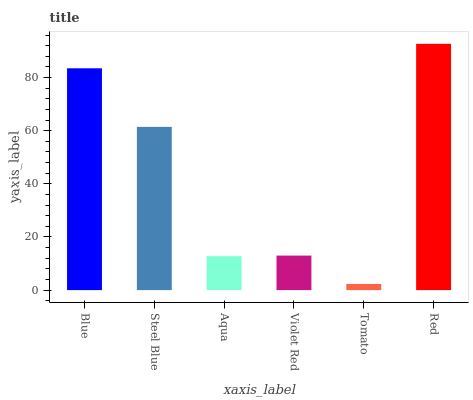Is Tomato the minimum?
Answer yes or no. Yes. Is Red the maximum?
Answer yes or no. Yes. Is Steel Blue the minimum?
Answer yes or no. No. Is Steel Blue the maximum?
Answer yes or no. No. Is Blue greater than Steel Blue?
Answer yes or no. Yes. Is Steel Blue less than Blue?
Answer yes or no. Yes. Is Steel Blue greater than Blue?
Answer yes or no. No. Is Blue less than Steel Blue?
Answer yes or no. No. Is Steel Blue the high median?
Answer yes or no. Yes. Is Violet Red the low median?
Answer yes or no. Yes. Is Red the high median?
Answer yes or no. No. Is Red the low median?
Answer yes or no. No. 